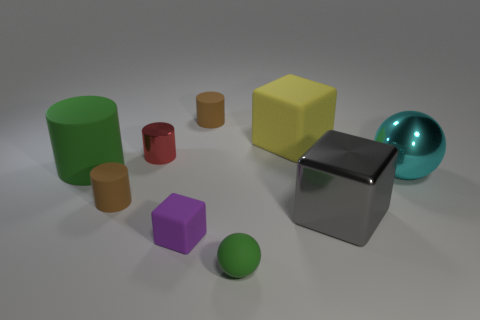Subtract all big blocks. How many blocks are left? 1 Subtract all blue blocks. How many brown cylinders are left? 2 Subtract all red cylinders. How many cylinders are left? 3 Subtract all spheres. How many objects are left? 7 Add 7 brown objects. How many brown objects are left? 9 Add 4 small green matte things. How many small green matte things exist? 5 Subtract 0 brown spheres. How many objects are left? 9 Subtract all green spheres. Subtract all yellow cylinders. How many spheres are left? 1 Subtract all metal cylinders. Subtract all brown cylinders. How many objects are left? 6 